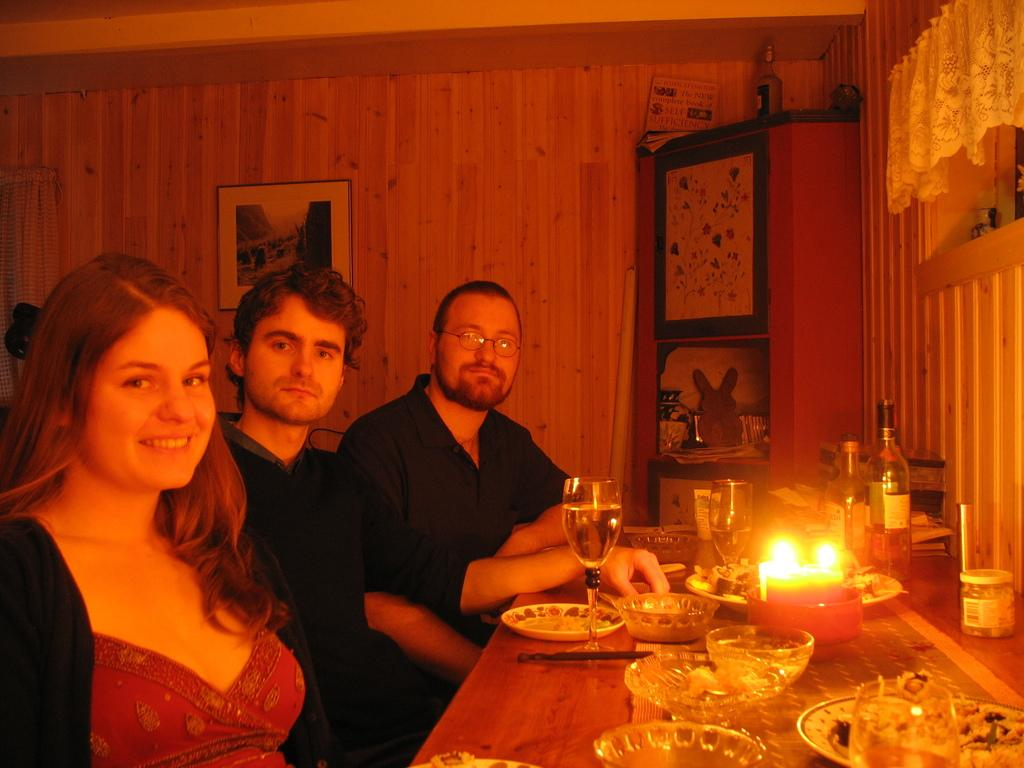How many people are sitting in the image? There are three people sitting on chairs in the image. What objects can be seen on the table? There is a plate, a bowl, a glass, a candle, and a bottle on the table. What is the frame attached to in the image? The frame is attached to a wooden wall. How does the frame increase the value of the painting in the image? There is no painting present in the image, so it is not possible to determine how the frame might increase its value. 